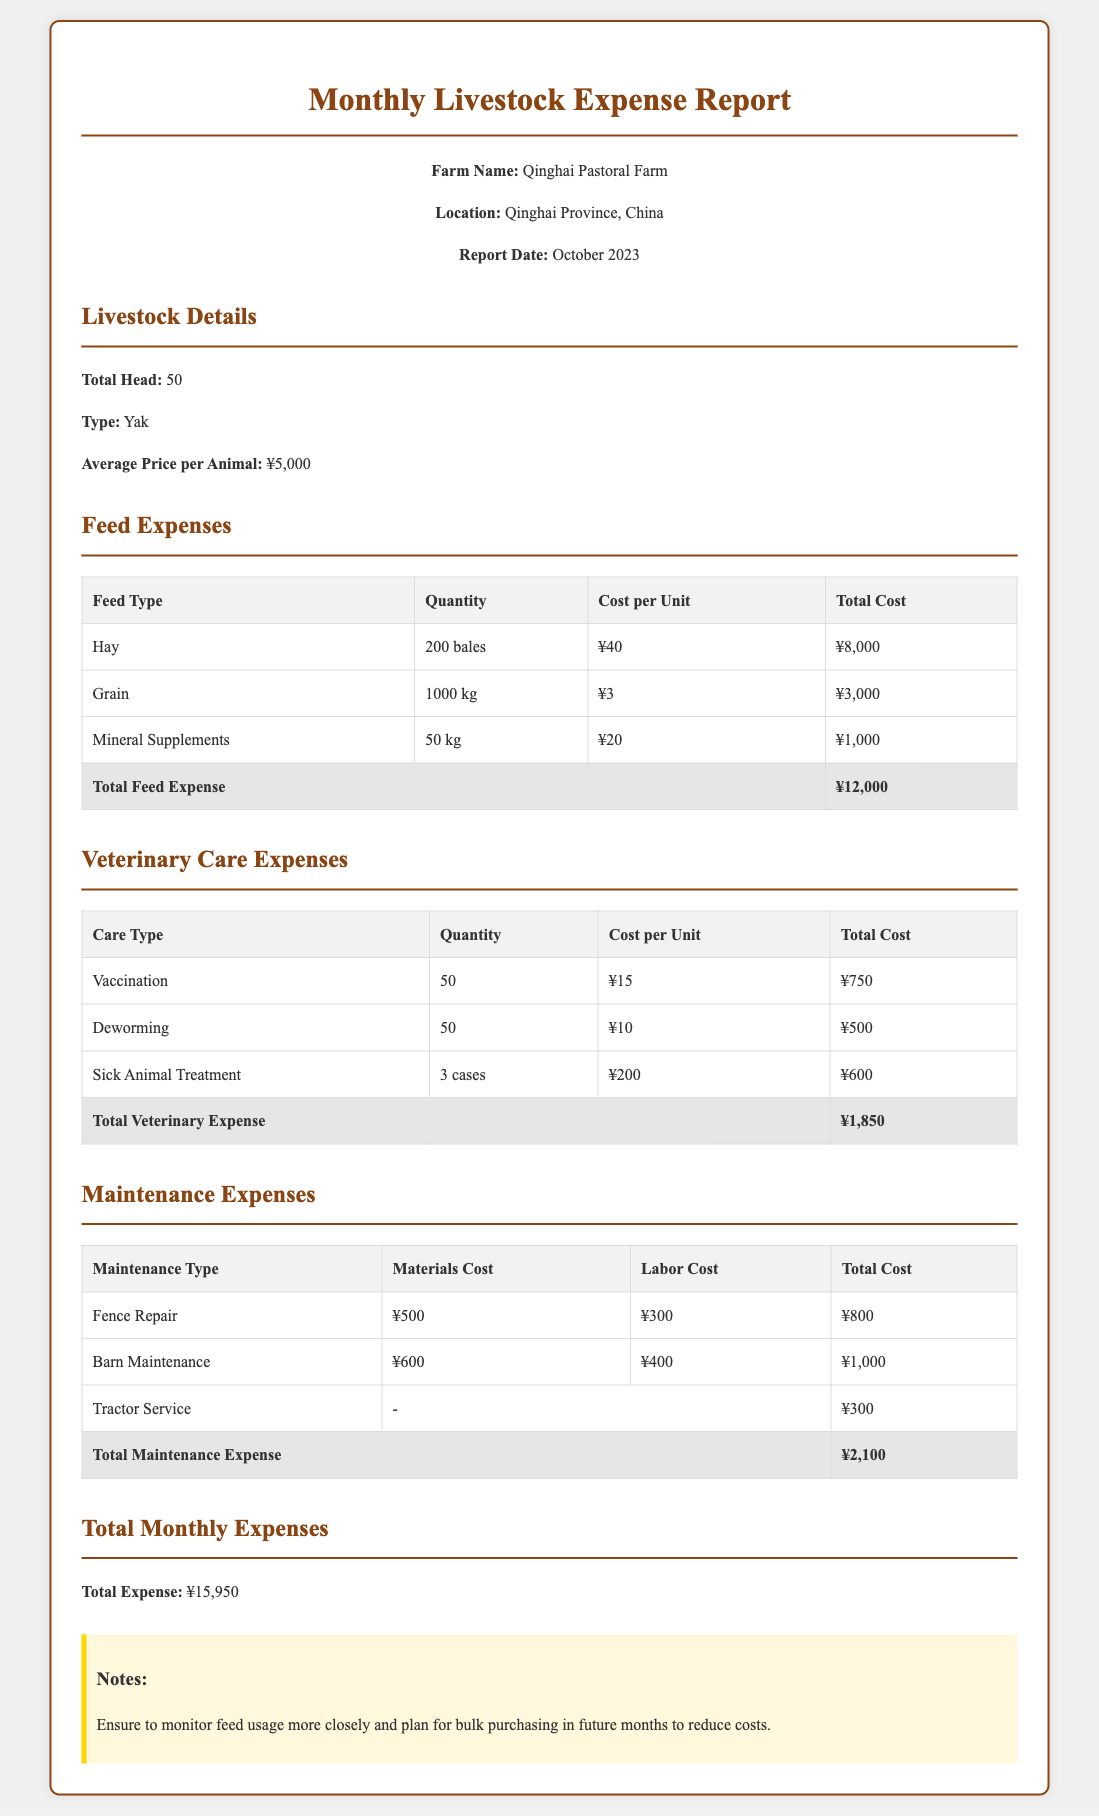What is the total head of livestock? The total head of livestock is stated in the report under Livestock Details.
Answer: 50 What is the average price per animal? The average price per animal is mentioned in the Livestock Details section.
Answer: ¥5,000 How much was spent on hay? The expense for hay is given in the Feed Expenses table.
Answer: ¥8,000 What is the total cost for veterinary care expenses? The total cost for veterinary care is calculated and presented at the end of the Veterinary Care Expenses table.
Answer: ¥1,850 What type of livestock is being reported on? The type of livestock is specified in the Livestock Details section.
Answer: Yak What is the total maintenance expense? The total maintenance expense is summarized at the end of the Maintenance Expenses table.
Answer: ¥2,100 What is the total monthly expense? The total monthly expense is outlined in the Total Monthly Expenses section of the document.
Answer: ¥15,950 How many cases of sick animal treatment were reported? The number of cases for sick animal treatment is listed in the Veterinary Care Expenses table.
Answer: 3 cases What should be monitored more closely according to the notes? A recommendation in the notes suggests an area for improvement.
Answer: Feed usage 